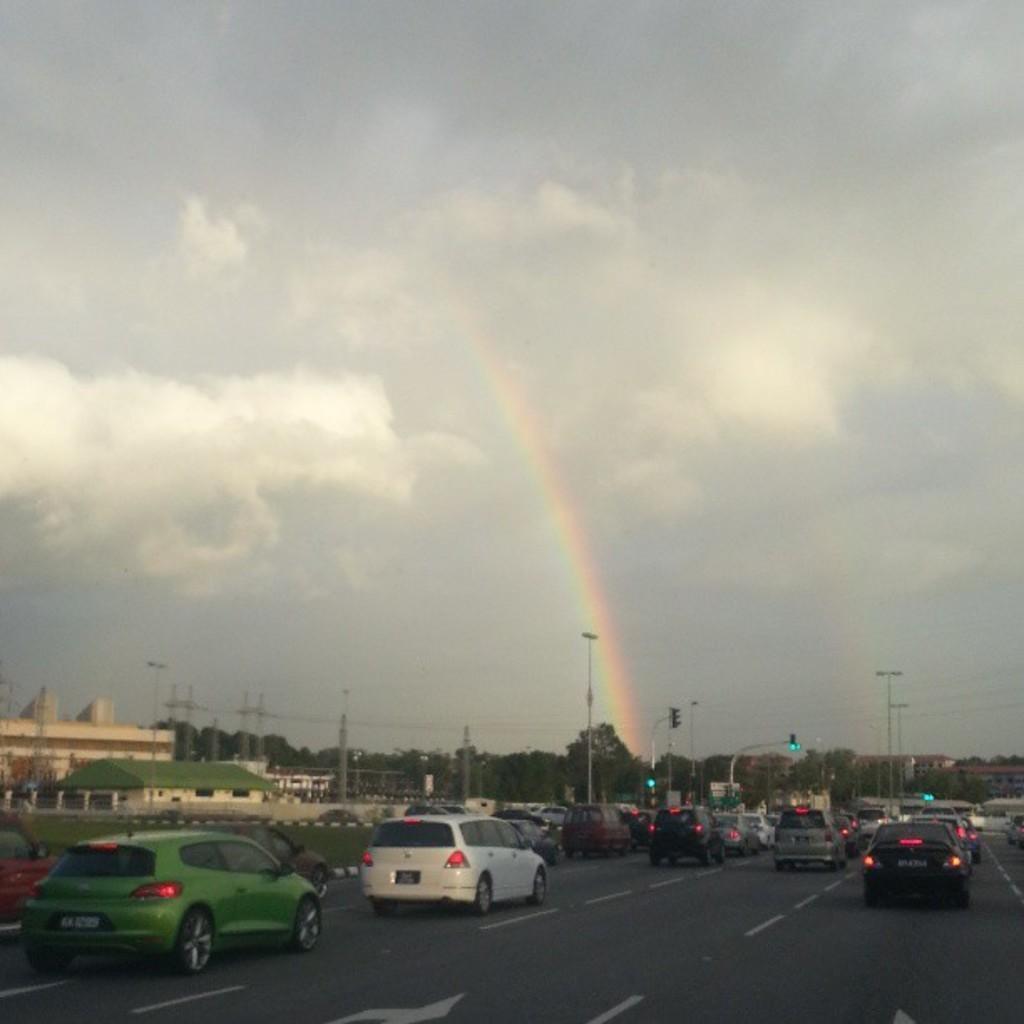Can you describe this image briefly? In this picture I can observe some cars moving on the road. In the background I can observe trees. There is a rainbow in the sky. I can observe some clouds in the sky. 